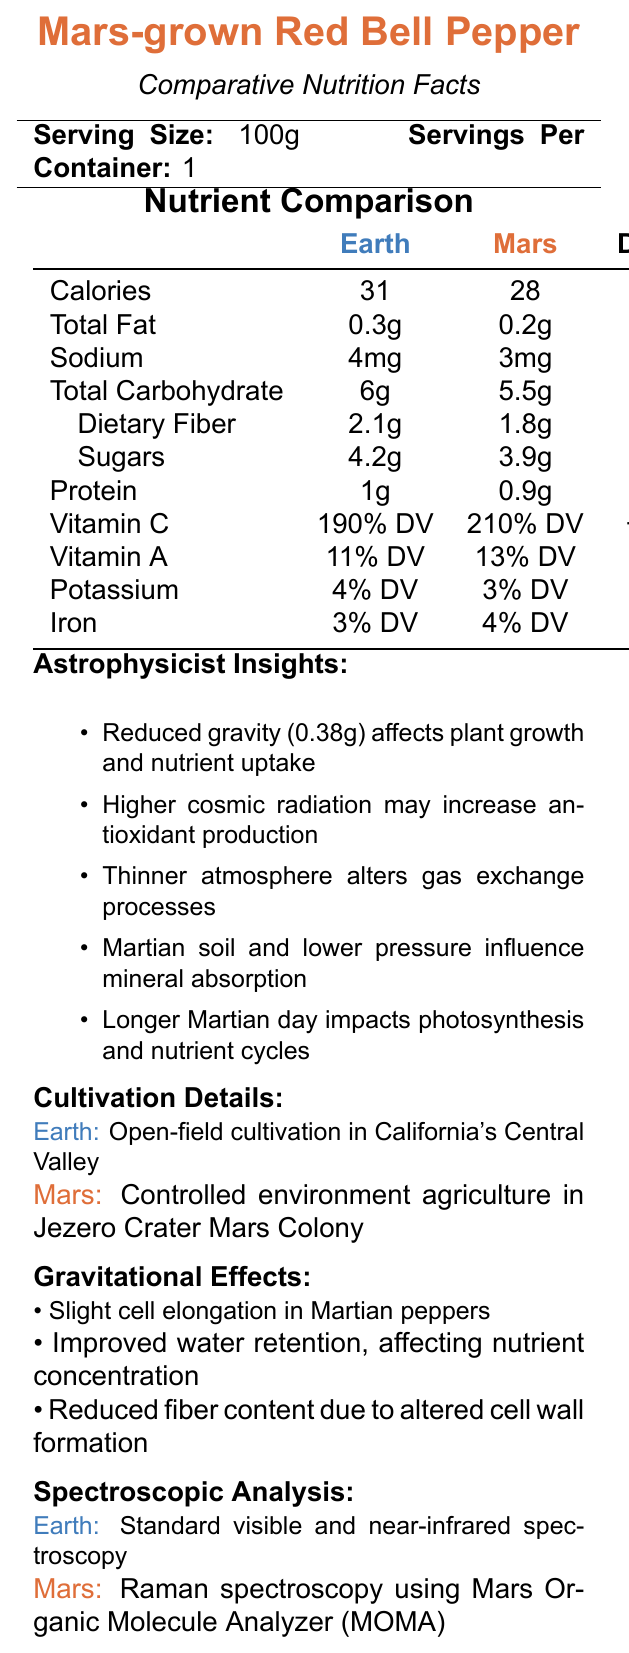what is the serving size of Mars-grown Red Bell Pepper? The serving size is explicitly stated at the top of the document.
Answer: 100g how many calories are in a serving of Mars-grown Red Bell Pepper? The calorie content for Mars-grown Red Bell Pepper is listed under the nutrient comparison section.
Answer: 28 how does the total fat content of Earth-grown Red Bell Pepper compare to Mars-grown Red Bell Pepper? The total fat content for both Earth and Mars-grown peppers is stated in the nutrient comparison table.
Answer: Earth-grown has 0.3g, Mars-grown has 0.2g how much sodium is present in Mars-grown Red Bell Pepper? The sodium content for Mars-grown Red Bell Pepper is listed in the nutrient comparison section.
Answer: 3mg what is the Dietary Fiber content of Mars-grown Red Bell Pepper? The dietary fiber content for Mars-grown Red Bell Pepper is provided in the nutrient comparison section.
Answer: 1.8g how does the protein content differ between Earth-grown and Mars-grown Red Bell Peppers? The protein content for both Earth and Mars-grown peppers is specified in the nutrient comparison table.
Answer: Earth-grown has 1g, Mars-grown has 0.9g what is one effect of reduced gravity on Mars-grown peppers? The gravitational effects section mentions slight cell elongation in Martian peppers due to reduced gravity.
Answer: Slight cell elongation which of the following nutrients is higher in Mars-grown peppers compared to Earth-grown peppers? A. Calories B. Total Fat C. Sodium D. Vitamin C The Vitamin C content is higher in Mars-grown peppers (210% DV vs. 190% DV).
Answer: D. Vitamin C what is the cultivation environment for Mars-grown Red Bell Pepper? A. Open-field cultivation B. Aeroponics C. Controlled environment agriculture D. Greenhouse The document states that Mars-grown Red Bell Pepper is cultivated in a controlled environment in Jezero Crater Mars Colony.
Answer: C. Controlled environment agriculture is the potassium content higher or lower in Mars-grown Red Bell Peppers compared to Earth-grown Red Bell Peppers? The potassium content in Mars-grown peppers is 3% DV, whereas in Earth-grown peppers it is 4% DV.
Answer: Lower describe the main differences in nutrient content between Earth-grown and Mars-grown Red Bell Peppers observed in the document. The nutrient comparison table in the document provides a detailed breakdown of the differences in nutrient content between Earth-grown and Mars-grown Red Bell Peppers, showing a consistent pattern of slightly reduced macronutrients but increased vitamin content in Mars-grown peppers.
Answer: Mars-grown Red Bell Peppers tend to have slightly lower macronutrients such as calories, total fat, sodium, total carbohydrates, dietary fiber, sugars, and protein compared to Earth-grown ones. However, they have higher vitamin C and vitamin A contents, indicating potential nutrient enrichment possibly due to Mars' environmental stressors like cosmic radiation. what type of spectroscopy is used for Mars-grown peppers? The spectroscopic analysis section states that Raman spectroscopy with MOMA is used for Mars-grown peppers.
Answer: Raman spectroscopy using Mars Organic Molecule Analyzer (MOMA) can the exact soil composition of the Martian environment be determined from this document? The document mentions Martian soil composition and its influence on mineral absorption but does not provide exact details about the soil composition.
Answer: Cannot be determined 